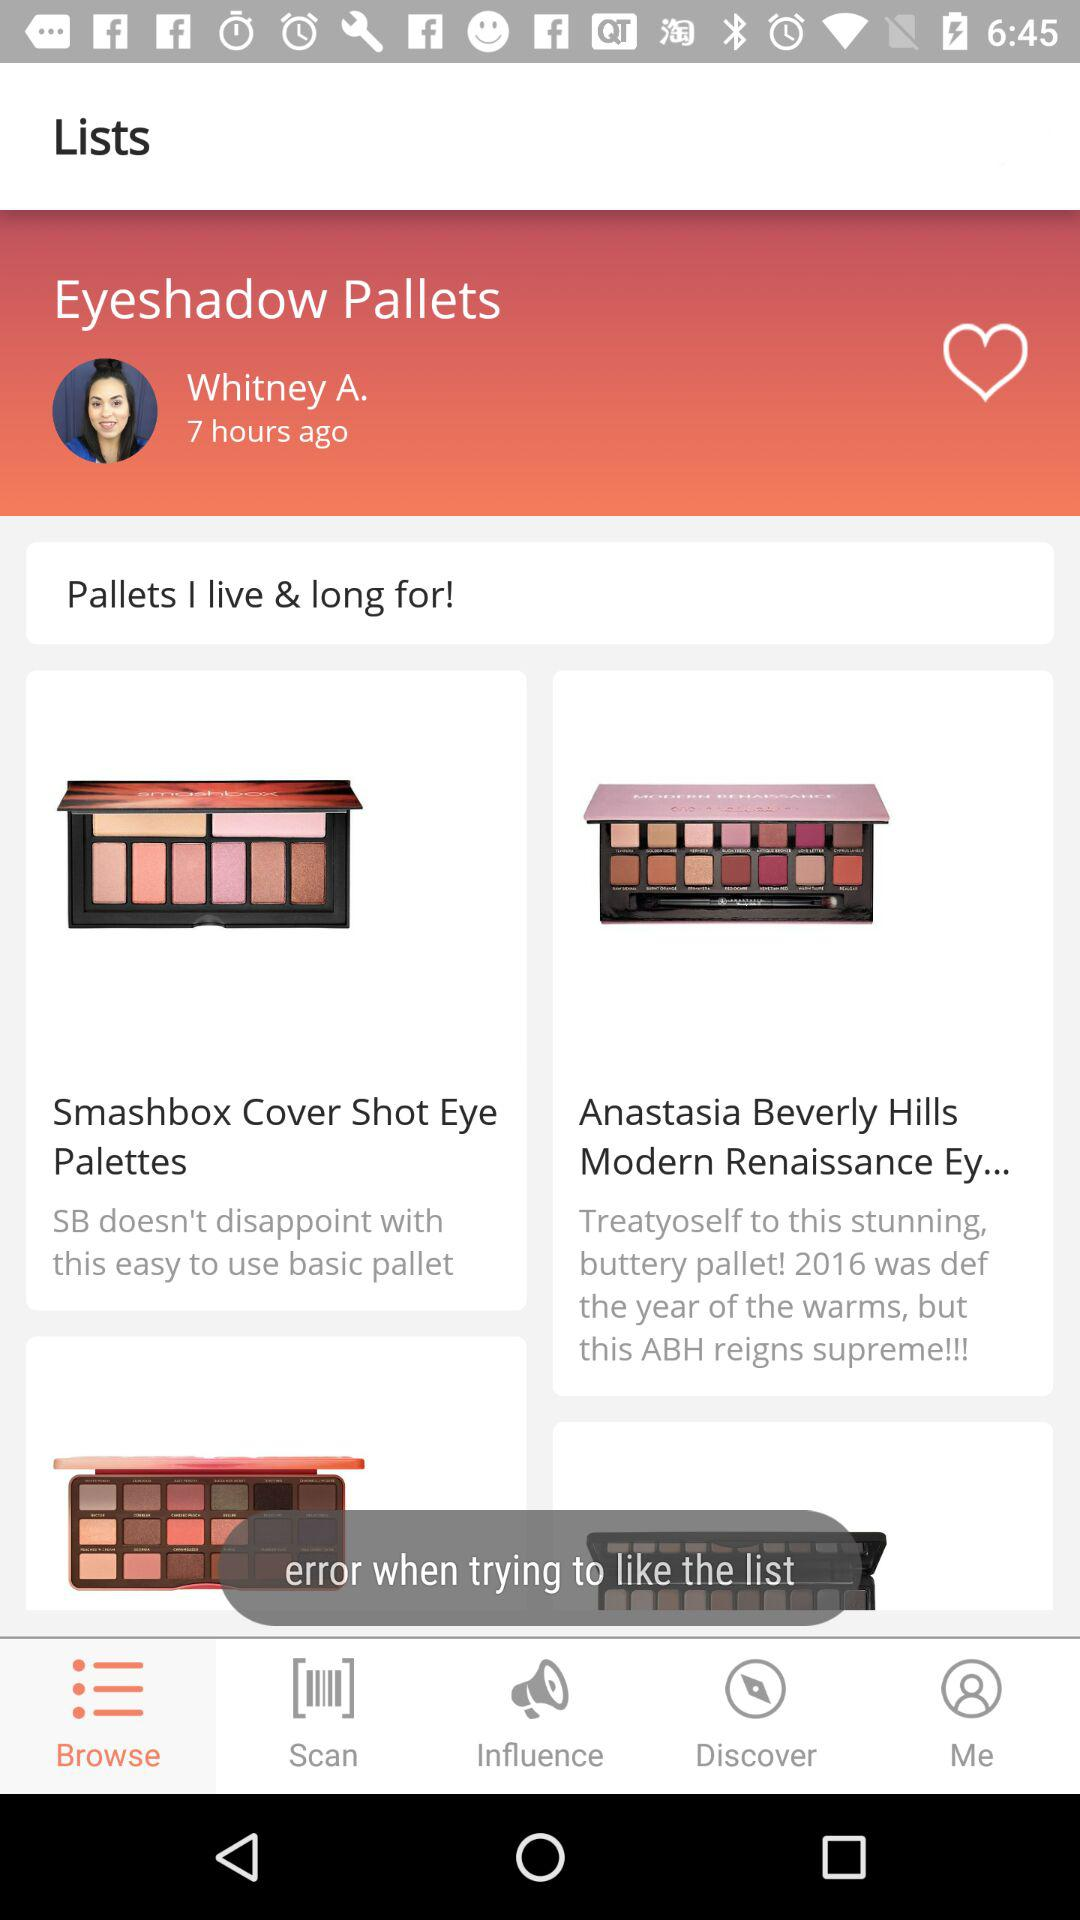Which are the different eyeshadow palettes? The different eyeshadow palettes are "Smashbox Cover Shot Eye Palettes" and "Anastasia Beverly Hills Modern Renaissance Ey...". 